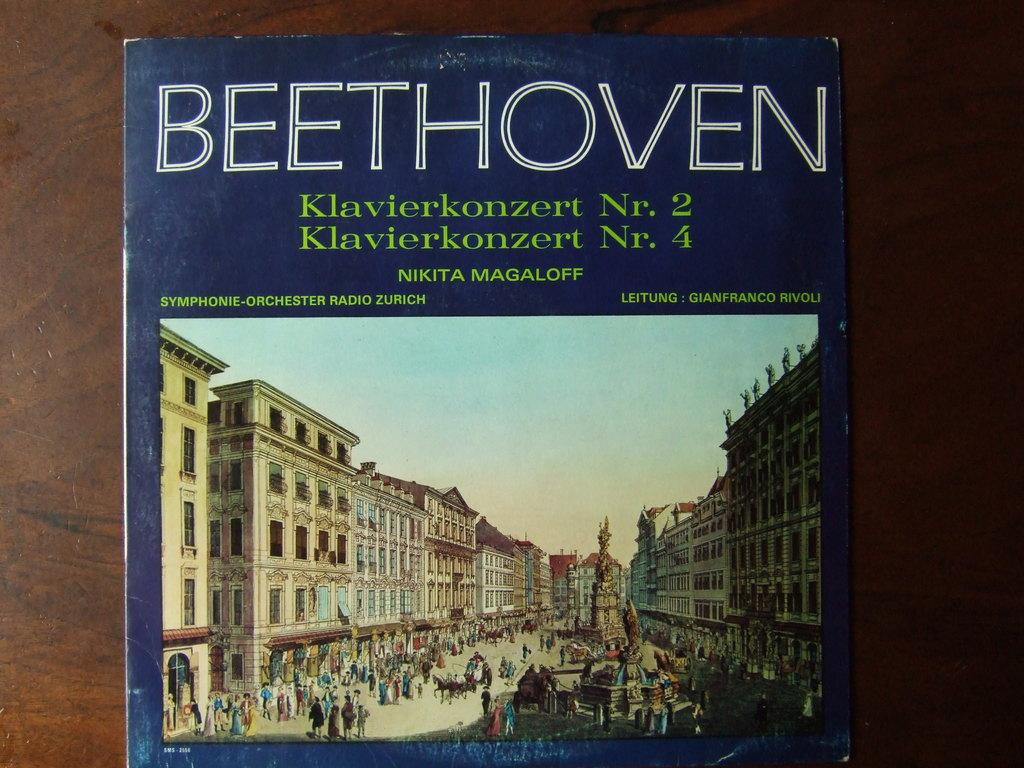<image>
Relay a brief, clear account of the picture shown. A blue cover with a city scene on front has :"Beethoven" in white letters. 